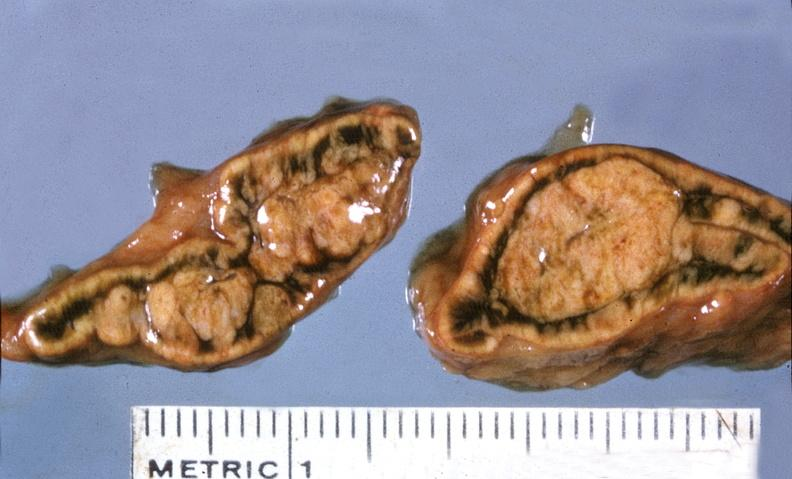s endocrine present?
Answer the question using a single word or phrase. Yes 